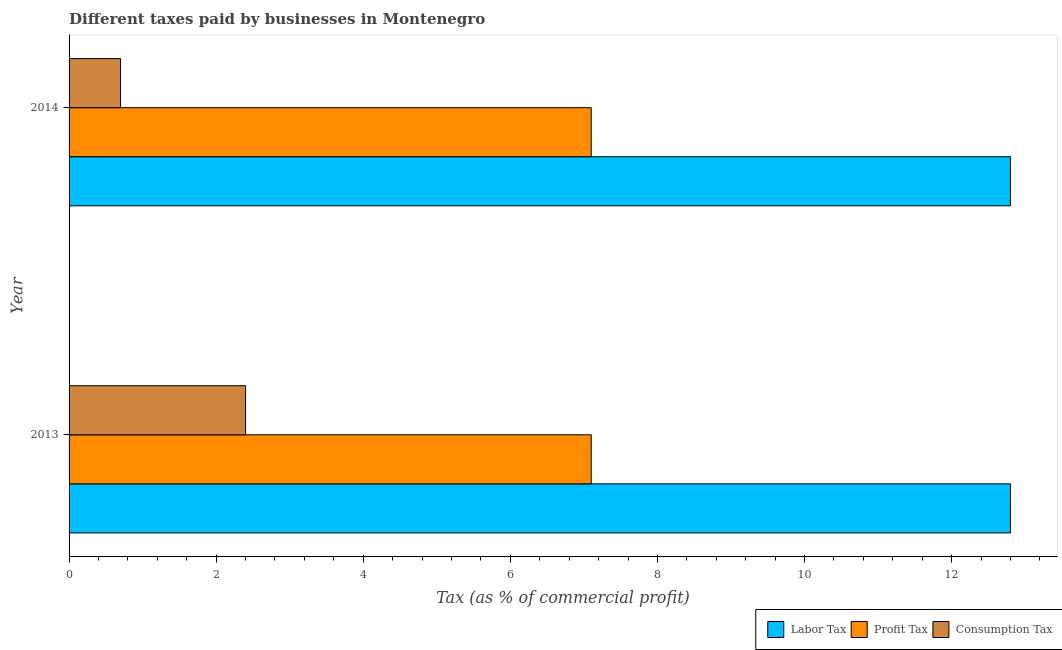Are the number of bars on each tick of the Y-axis equal?
Offer a very short reply. Yes. How many bars are there on the 1st tick from the bottom?
Keep it short and to the point. 3. What is the label of the 1st group of bars from the top?
Offer a terse response. 2014. What is the percentage of consumption tax in 2013?
Ensure brevity in your answer.  2.4. Across all years, what is the maximum percentage of consumption tax?
Your answer should be compact. 2.4. Across all years, what is the minimum percentage of profit tax?
Ensure brevity in your answer.  7.1. What is the total percentage of consumption tax in the graph?
Your response must be concise. 3.1. What is the difference between the percentage of labor tax in 2013 and the percentage of consumption tax in 2014?
Your response must be concise. 12.1. In the year 2014, what is the difference between the percentage of profit tax and percentage of labor tax?
Offer a terse response. -5.7. In how many years, is the percentage of consumption tax greater than 1.6 %?
Provide a short and direct response. 1. What is the ratio of the percentage of profit tax in 2013 to that in 2014?
Keep it short and to the point. 1. Is the percentage of consumption tax in 2013 less than that in 2014?
Your answer should be very brief. No. Is the difference between the percentage of labor tax in 2013 and 2014 greater than the difference between the percentage of profit tax in 2013 and 2014?
Provide a short and direct response. No. In how many years, is the percentage of profit tax greater than the average percentage of profit tax taken over all years?
Provide a succinct answer. 0. What does the 1st bar from the top in 2014 represents?
Ensure brevity in your answer.  Consumption Tax. What does the 3rd bar from the bottom in 2013 represents?
Your response must be concise. Consumption Tax. Are all the bars in the graph horizontal?
Your response must be concise. Yes. How many years are there in the graph?
Keep it short and to the point. 2. What is the difference between two consecutive major ticks on the X-axis?
Provide a succinct answer. 2. Are the values on the major ticks of X-axis written in scientific E-notation?
Give a very brief answer. No. What is the title of the graph?
Ensure brevity in your answer.  Different taxes paid by businesses in Montenegro. Does "Tertiary education" appear as one of the legend labels in the graph?
Ensure brevity in your answer.  No. What is the label or title of the X-axis?
Offer a terse response. Tax (as % of commercial profit). What is the Tax (as % of commercial profit) of Profit Tax in 2014?
Provide a short and direct response. 7.1. Across all years, what is the maximum Tax (as % of commercial profit) in Labor Tax?
Give a very brief answer. 12.8. Across all years, what is the maximum Tax (as % of commercial profit) in Profit Tax?
Offer a terse response. 7.1. Across all years, what is the minimum Tax (as % of commercial profit) in Labor Tax?
Offer a terse response. 12.8. What is the total Tax (as % of commercial profit) in Labor Tax in the graph?
Provide a succinct answer. 25.6. What is the total Tax (as % of commercial profit) of Consumption Tax in the graph?
Make the answer very short. 3.1. What is the difference between the Tax (as % of commercial profit) in Labor Tax in 2013 and that in 2014?
Your answer should be very brief. 0. What is the difference between the Tax (as % of commercial profit) of Profit Tax in 2013 and that in 2014?
Provide a succinct answer. 0. What is the difference between the Tax (as % of commercial profit) of Consumption Tax in 2013 and that in 2014?
Provide a short and direct response. 1.7. What is the difference between the Tax (as % of commercial profit) in Labor Tax in 2013 and the Tax (as % of commercial profit) in Profit Tax in 2014?
Offer a terse response. 5.7. What is the difference between the Tax (as % of commercial profit) in Labor Tax in 2013 and the Tax (as % of commercial profit) in Consumption Tax in 2014?
Make the answer very short. 12.1. What is the difference between the Tax (as % of commercial profit) in Profit Tax in 2013 and the Tax (as % of commercial profit) in Consumption Tax in 2014?
Offer a terse response. 6.4. What is the average Tax (as % of commercial profit) in Labor Tax per year?
Your answer should be compact. 12.8. What is the average Tax (as % of commercial profit) of Consumption Tax per year?
Make the answer very short. 1.55. In the year 2013, what is the difference between the Tax (as % of commercial profit) of Labor Tax and Tax (as % of commercial profit) of Profit Tax?
Ensure brevity in your answer.  5.7. In the year 2013, what is the difference between the Tax (as % of commercial profit) of Labor Tax and Tax (as % of commercial profit) of Consumption Tax?
Your answer should be compact. 10.4. In the year 2013, what is the difference between the Tax (as % of commercial profit) in Profit Tax and Tax (as % of commercial profit) in Consumption Tax?
Offer a very short reply. 4.7. In the year 2014, what is the difference between the Tax (as % of commercial profit) of Labor Tax and Tax (as % of commercial profit) of Profit Tax?
Your response must be concise. 5.7. What is the ratio of the Tax (as % of commercial profit) in Profit Tax in 2013 to that in 2014?
Offer a very short reply. 1. What is the ratio of the Tax (as % of commercial profit) in Consumption Tax in 2013 to that in 2014?
Provide a short and direct response. 3.43. What is the difference between the highest and the lowest Tax (as % of commercial profit) of Labor Tax?
Offer a terse response. 0. What is the difference between the highest and the lowest Tax (as % of commercial profit) of Consumption Tax?
Offer a terse response. 1.7. 